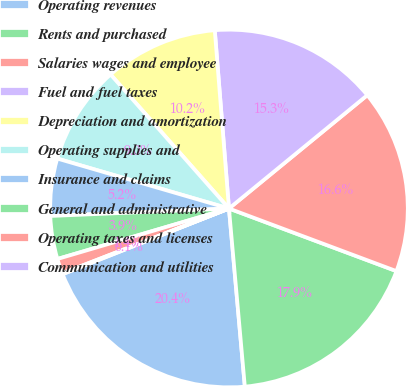Convert chart. <chart><loc_0><loc_0><loc_500><loc_500><pie_chart><fcel>Operating revenues<fcel>Rents and purchased<fcel>Salaries wages and employee<fcel>Fuel and fuel taxes<fcel>Depreciation and amortization<fcel>Operating supplies and<fcel>Insurance and claims<fcel>General and administrative<fcel>Operating taxes and licenses<fcel>Communication and utilities<nl><fcel>20.43%<fcel>17.89%<fcel>16.62%<fcel>15.34%<fcel>10.25%<fcel>8.98%<fcel>5.17%<fcel>3.89%<fcel>1.35%<fcel>0.08%<nl></chart> 